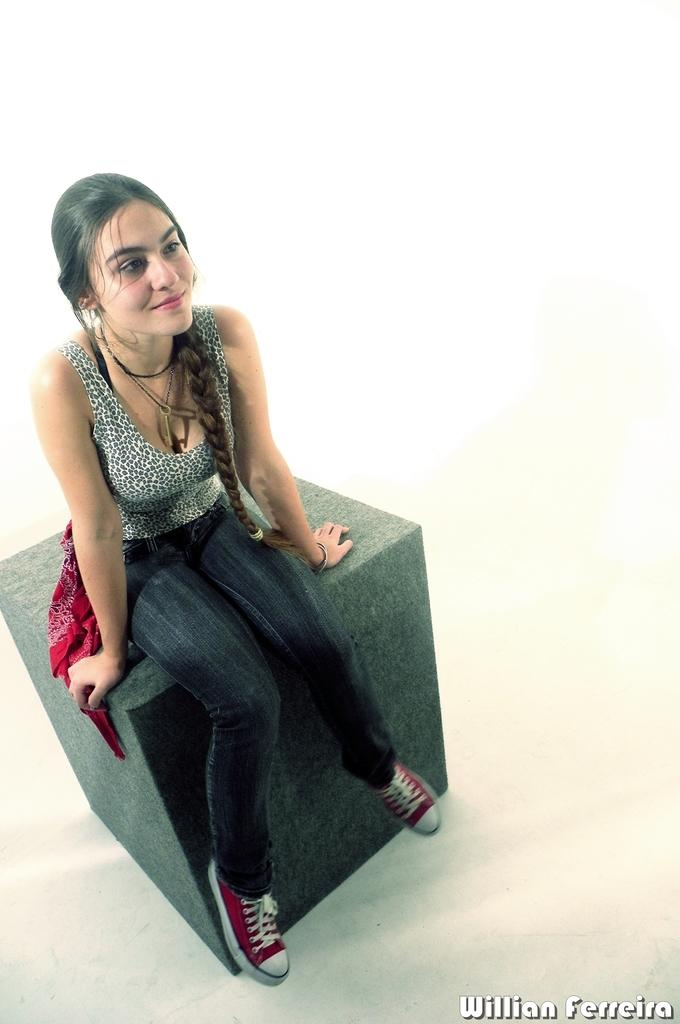What is the person in the image sitting on? The person is sitting on a gray color surface. What is the person wearing in the image? The person is wearing a black and white color dress. What color is the background of the image? The background of the image is white. What type of chain is being offered to the person in the image? There is no chain or offer present in the image; it only features a person sitting on a gray surface and wearing a black and white dress against a white background. 